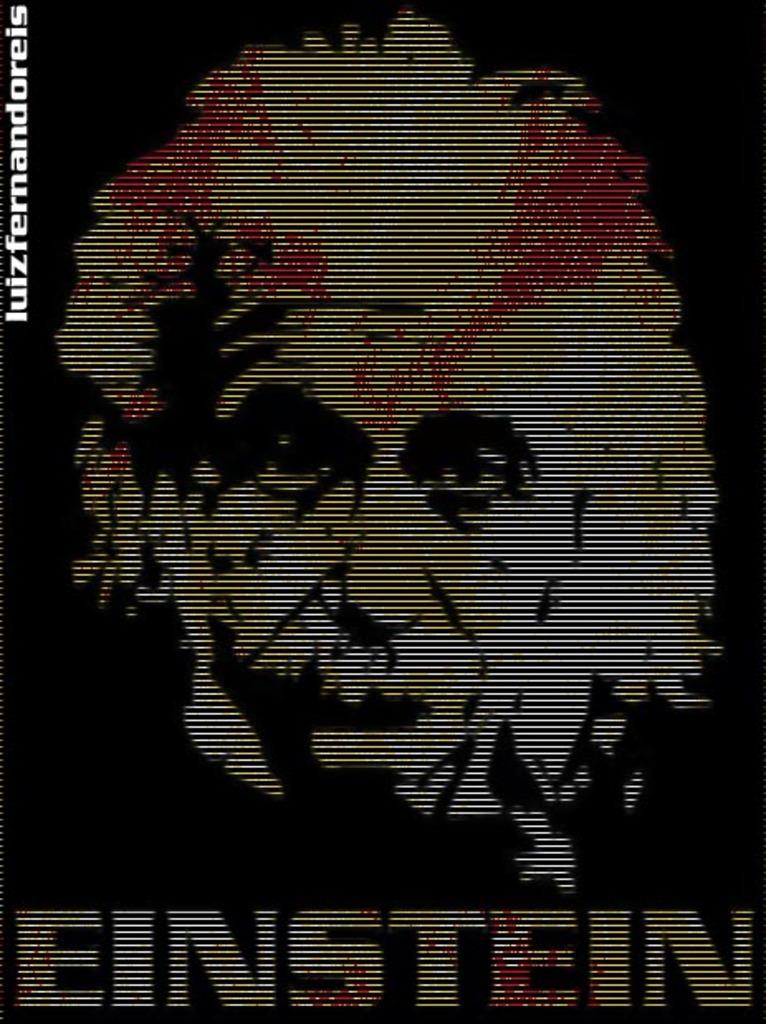Who is in the poster?
Your response must be concise. Einstein. What is the name on the poster ?
Keep it short and to the point. Einstein. 